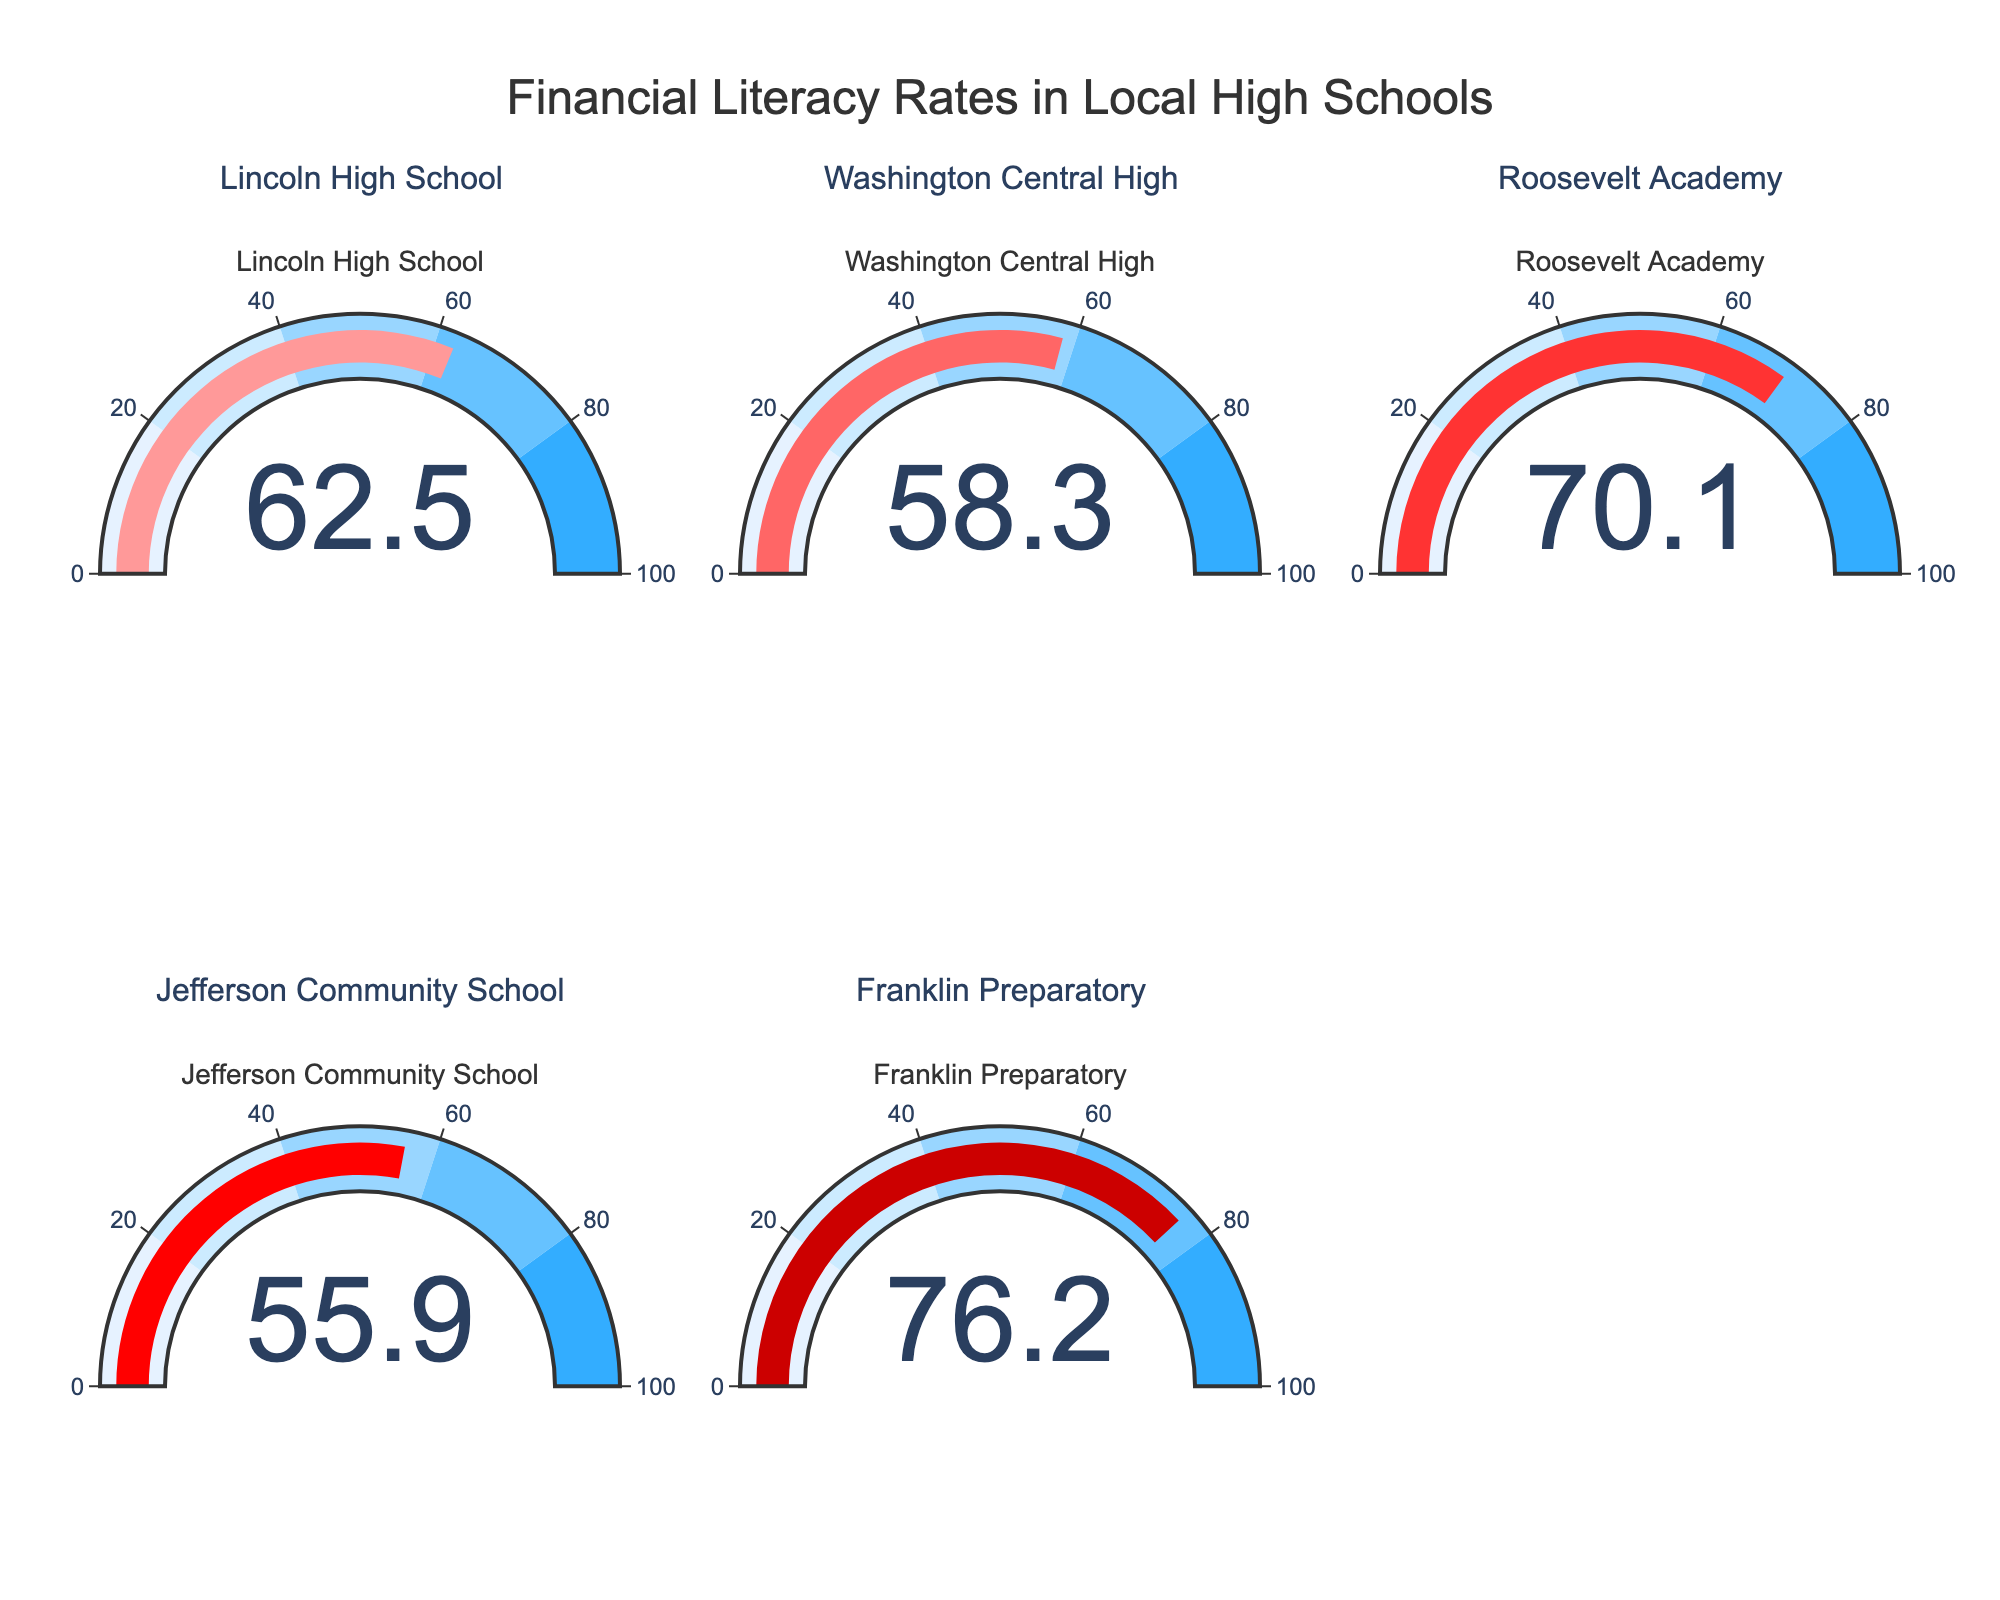What's the title of the figure? The title of the figure is displayed prominently at the top. It reads, "Financial Literacy Rates in Local High Schools"
Answer: Financial Literacy Rates in Local High Schools How many high schools are represented in the plot? There are five subplots, each representing a different high school.
Answer: Five Which high school has the highest financial literacy rate? By examining the gauge charts, Franklin Preparatory shows the highest financial literacy rate at 76.2.
Answer: Franklin Preparatory What's the financial literacy rate of Roosevelt Academy? The gauge chart for Roosevelt Academy indicates a financial literacy rate of 70.1.
Answer: 70.1 Which high school has the lowest financial literacy rate? By comparing the values on each gauge chart, Jefferson Community School has the lowest financial literacy rate at 55.9.
Answer: Jefferson Community School What is the average financial literacy rate among these high schools? Sum the financial literacy rates of all five high schools: 62.5 + 58.3 + 70.1 + 55.9 + 76.2 = 323. Then divide by the number of schools, 323 / 5 = 64.6.
Answer: 64.6 Which schools have a financial literacy rate greater than 60? From the gauge charts, Lincoln High School (62.5), Roosevelt Academy (70.1), and Franklin Preparatory (76.2) have rates greater than 60.
Answer: Lincoln High School, Roosevelt Academy, Franklin Preparatory What is the range of financial literacy rates among the high schools? The highest rate is 76.2 (Franklin Preparatory), and the lowest is 55.9 (Jefferson Community School). The range is 76.2 - 55.9 = 20.3.
Answer: 20.3 What is the median financial literacy rate? Arrange the rates in ascending order: 55.9, 58.3, 62.5, 70.1, 76.2. The median is the middle value, which is 62.5.
Answer: 62.5 Which school has a financial literacy rate close to the average? The calculated average is 64.6. The closest rate to this is Lincoln High School with 62.5.
Answer: Lincoln High School 